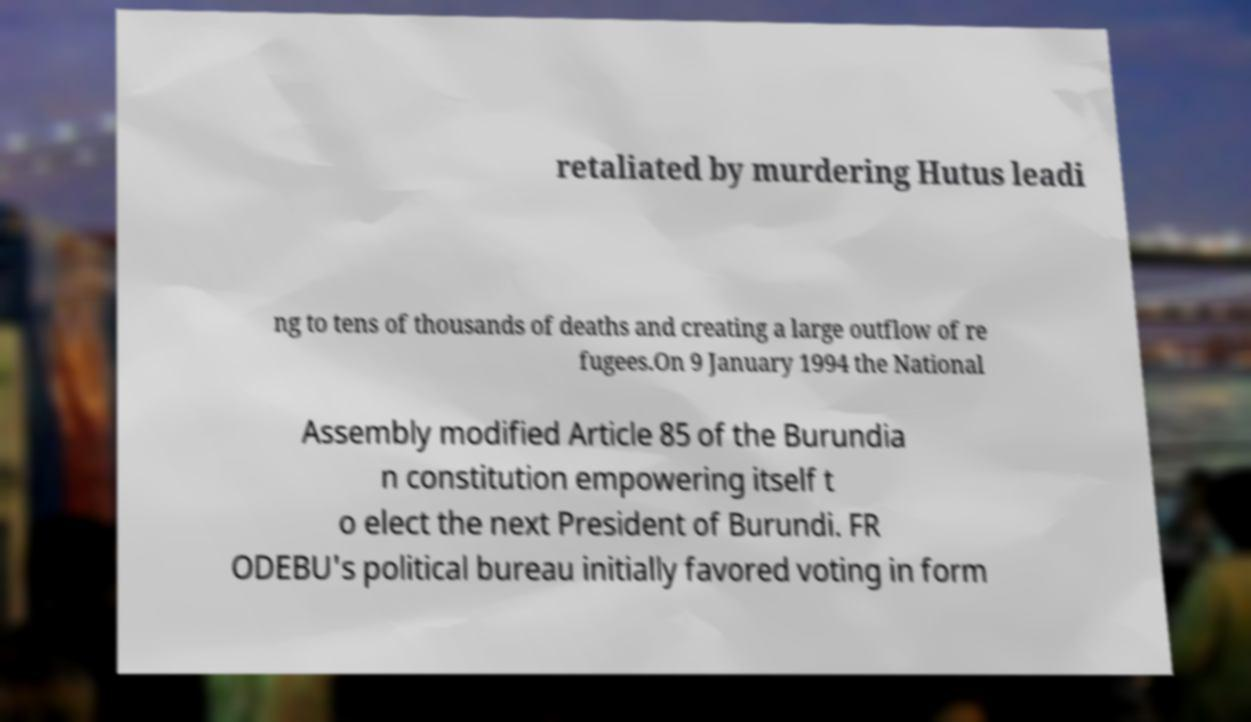Please read and relay the text visible in this image. What does it say? retaliated by murdering Hutus leadi ng to tens of thousands of deaths and creating a large outflow of re fugees.On 9 January 1994 the National Assembly modified Article 85 of the Burundia n constitution empowering itself t o elect the next President of Burundi. FR ODEBU's political bureau initially favored voting in form 